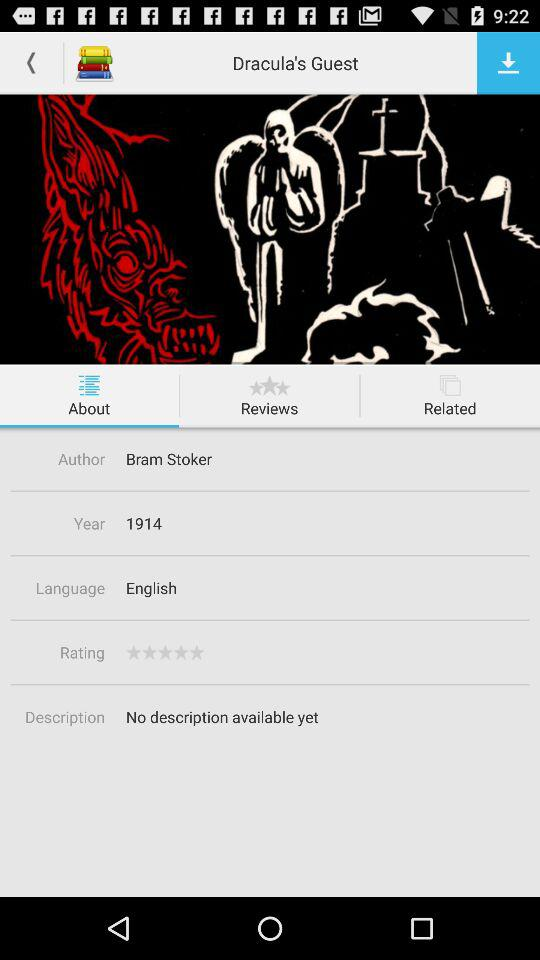What is the rating? The rating is 0 stars. 